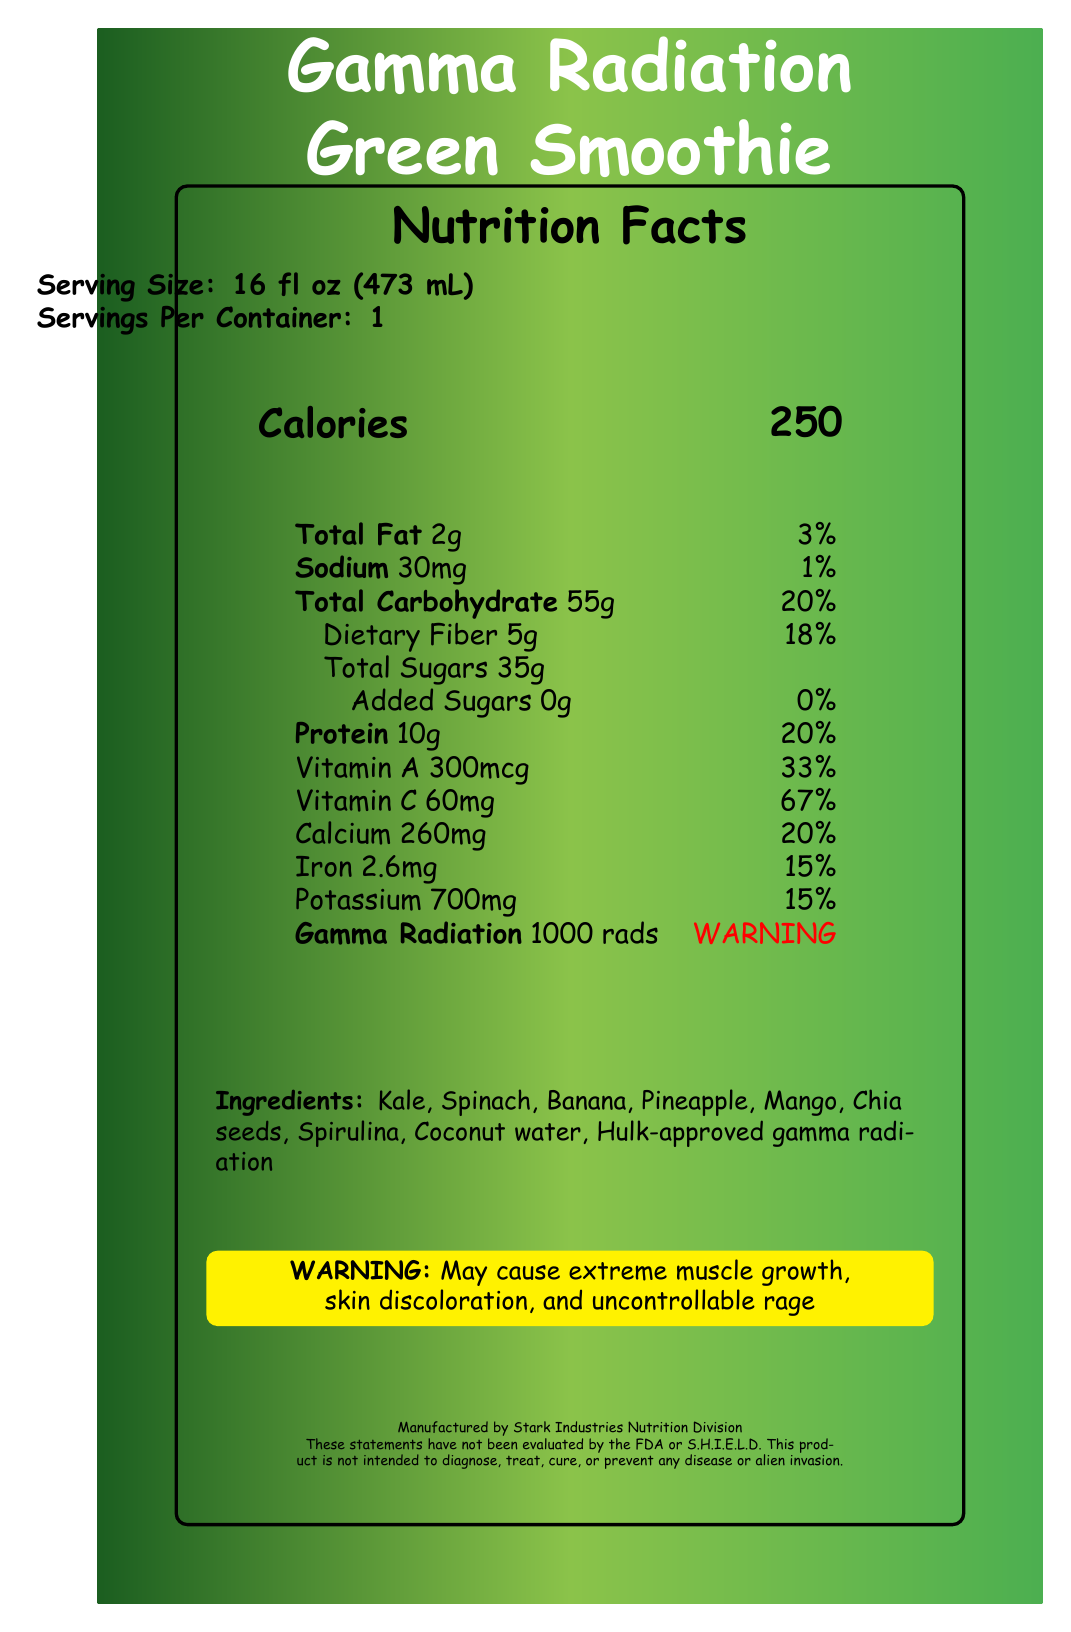what is the serving size of the Gamma Radiation Green Smoothie? The serving size is explicitly stated as 16 fl oz (473 mL) in the serving information section of the document.
Answer: 16 fl oz (473 mL) how many calories are in one serving of the Gamma Radiation Green Smoothie? The document shows "Calories" at the calorie section with a value of 250.
Answer: 250 what is the daily value percentage for protein in this smoothie? The nutrient table section indicates that Protein is 10g with a daily value percentage of 20%.
Answer: 20% what warnings are provided for consuming this product? The document has a warning section that mentions potential side effects from consuming the smoothie.
Answer: May cause extreme muscle growth, skin discoloration, and uncontrollable rage list three ingredients in the Gamma Radiation Green Smoothie. The ingredients section lists several components including Kale, Spinach, and Banana.
Answer: Kale, Spinach, Banana what is the daily value percentage for Vitamin C? In the nutrient table, Vitamin C is listed as having a daily value of 67%.
Answer: 67% how much dietary fiber does the Gamma Radiation Green Smoothie contain? A. 2g B. 5g C. 10g D. 20g The nutrient table specifies that the dietary fiber content is 5g.
Answer: B. 5g which of the following is NOT an ingredient in the smoothie? A. Kale B. Spinach C. Blueberry D. Coconut water Blueberry is not listed in the ingredients section of the document.
Answer: C. Blueberry is the Gamma Radiation Green Smoothie evaluated by the FDA or S.H.I.E.L.D.? A disclaimer at the bottom of the document indicates that the product has not been evaluated by the FDA or S.H.I.E.L.D.
Answer: No summarize the main idea of the Gamma Radiation Green Smoothie document. The entire document is centered around providing detailed nutritional information for the Gamma Radiation Green Smoothie, including potential health warnings and a Hulk-themed design.
Answer: The document is a Nutrition Facts Label for the Gamma Radiation Green Smoothie. It includes serving size, calorie content, a nutrient table, ingredients, warnings, warning symbols, manufacturer information, and a disclaimer. The label is visually designed with Hulk-inspired color gradients. what is the daily value percentage for total carbohydrate? The nutrient table lists the total carbohydrate of 55g with a 20% daily value.
Answer: 20% what is the serving amount for Calcium and its daily value percentage? In the nutrient table, Calcium is listed as 260mg with a daily value of 20%.
Answer: 260mg and 20% which manufacturer produces the Gamma Radiation Green Smoothie? The manufacturer section at the bottom of the document names Stark Industries Nutrition Division as the producer.
Answer: Stark Industries Nutrition Division does the Gamma Radiation Green Smoothie contain any common allergens? The allergen information section specifies that the product contains no common allergens.
Answer: No what are the warning symbols included in the document? List at least two. The warning symbols section lists three icons: Radiation hazard symbol, Biohazard symbol, and Hulk fist icon.
Answer: Radiation hazard symbol, Biohazard symbol, Hulk fist icon what is the meaning of "may cause extreme muscle growth, skin discoloration, and uncontrollable rage"? The warning section explains that these are potential side effects of drinking the Gamma Radiation Green Smoothie.
Answer: Side effects from consuming the smoothie describe the color gradient used in the document. The color gradient section indicates that the primary color is #1B5E20, secondary is #4CAF50, and tertiary is #8BC34A.
Answer: Primary: #1B5E20, Secondary: #4CAF50, Tertiary: #8BC34A how does gamma radiation affect safety when consuming this smoothie? The nutrient table warns that gamma radiation content exceeds safe limits, indicating potential danger.
Answer: WARNING: Exceeds safe limits what is the purpose of the disclaimer at the bottom of the document? The disclaimer's purpose is to inform consumers about the lack of official evaluation and diagnosis claims for the product.
Answer: To inform that the product has not been evaluated by the FDA or S.H.I.E.L.D. and is not intended to diagnose, treat, cure, or prevent any disease or alien invasion what is the recommended daily intake of vitamin A? The document does not provide information on the recommended daily intake of Vitamin A, only its percentage in this product.
Answer: Cannot be determined 